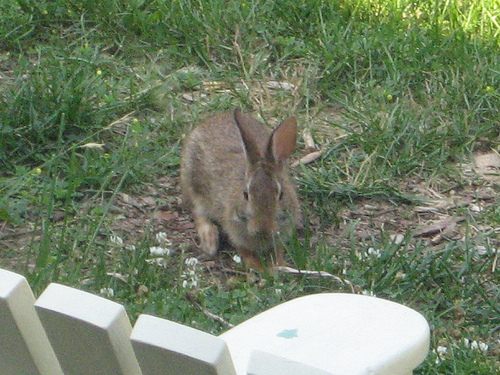<image>
Is the rabbit in front of the fence? Yes. The rabbit is positioned in front of the fence, appearing closer to the camera viewpoint. 